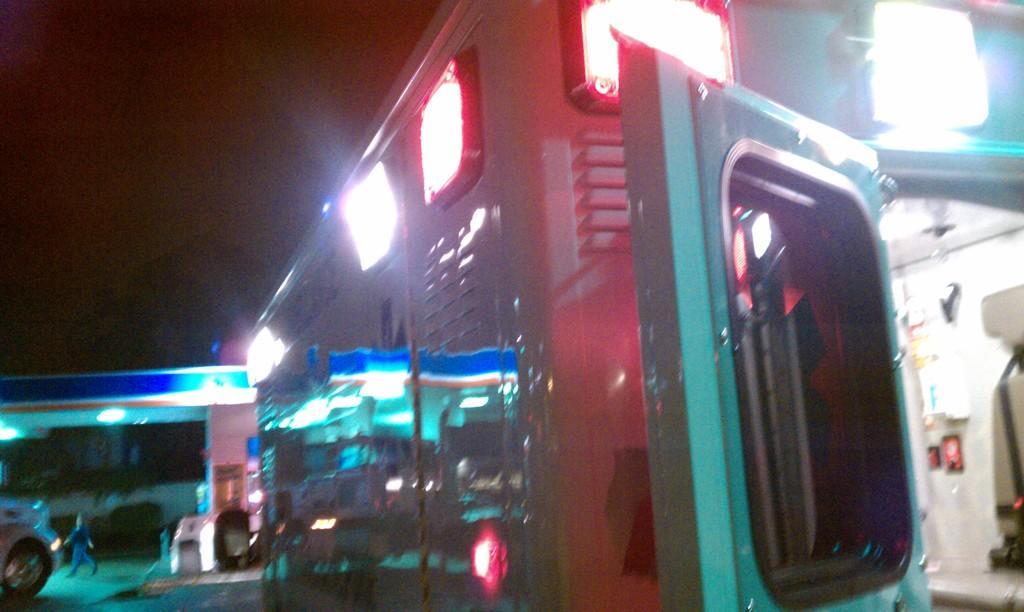Could you give a brief overview of what you see in this image? In this picture I can see on the right side it looks like a machine with lights, on the left side a person is walking. 